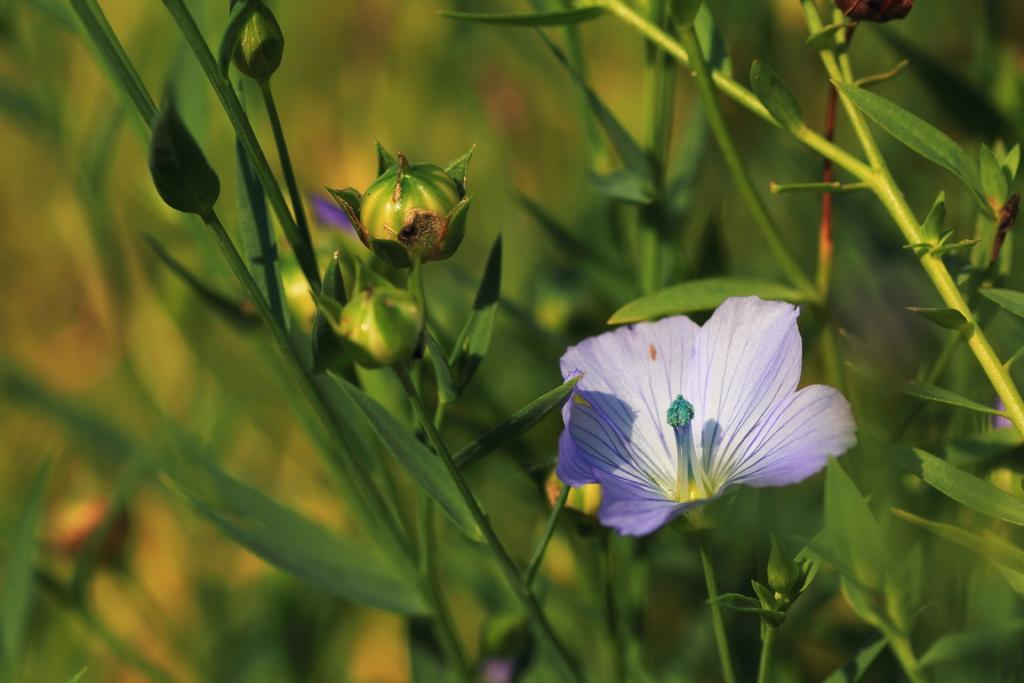What type of living organism can be seen in the image? There is a flower in the image. Are there any other plants visible in the image? Yes, there are plants in the image. How many cars can be seen driving through the flower in the image? There are no cars present in the image; it features a flower and plants. Is there a squirrel visible in the image? There is no squirrel present in the image. 